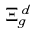<formula> <loc_0><loc_0><loc_500><loc_500>\Xi _ { g } ^ { d }</formula> 